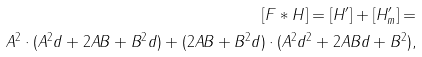<formula> <loc_0><loc_0><loc_500><loc_500>[ F \ast H ] = [ H ^ { \prime } ] + [ H _ { m } ^ { \prime } ] = \\ A ^ { 2 } \cdot ( A ^ { 2 } d + 2 A B + B ^ { 2 } d ) + ( 2 A B + B ^ { 2 } d ) \cdot ( A ^ { 2 } d ^ { 2 } + 2 A B d + B ^ { 2 } ) ,</formula> 